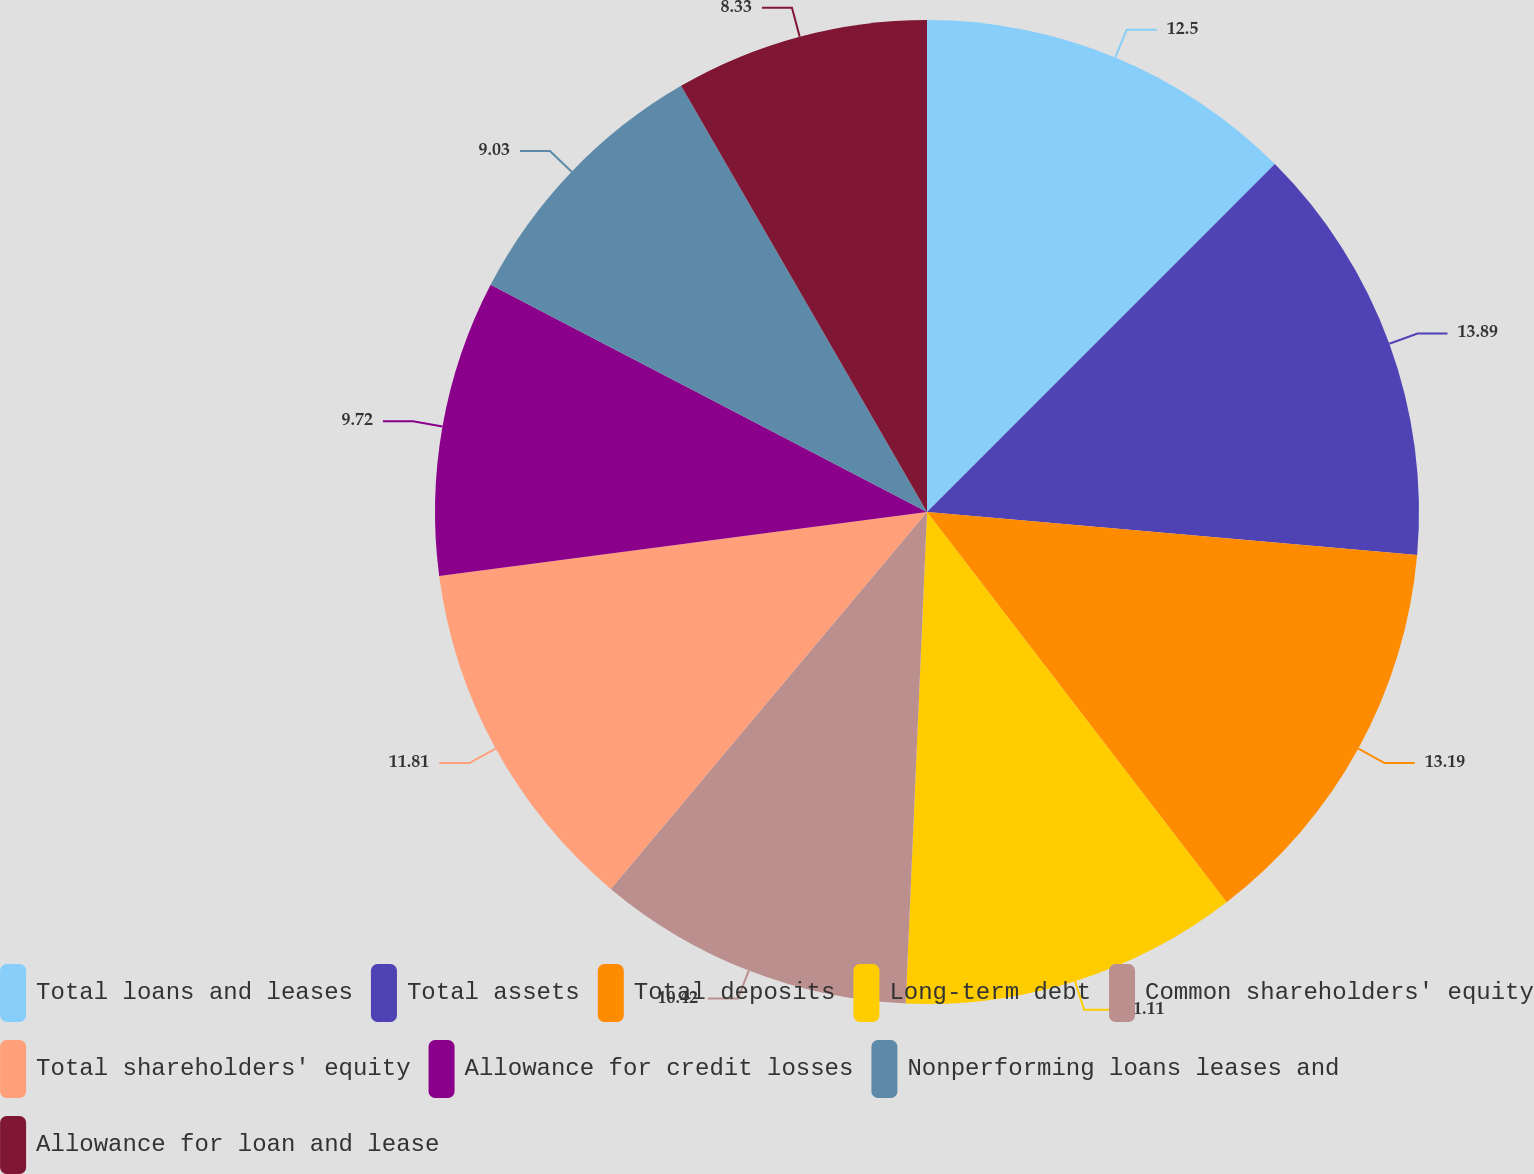<chart> <loc_0><loc_0><loc_500><loc_500><pie_chart><fcel>Total loans and leases<fcel>Total assets<fcel>Total deposits<fcel>Long-term debt<fcel>Common shareholders' equity<fcel>Total shareholders' equity<fcel>Allowance for credit losses<fcel>Nonperforming loans leases and<fcel>Allowance for loan and lease<nl><fcel>12.5%<fcel>13.89%<fcel>13.19%<fcel>11.11%<fcel>10.42%<fcel>11.81%<fcel>9.72%<fcel>9.03%<fcel>8.33%<nl></chart> 